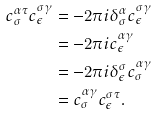Convert formula to latex. <formula><loc_0><loc_0><loc_500><loc_500>c _ { \sigma } ^ { \alpha \tau } c _ { \epsilon } ^ { \sigma \gamma } & = - 2 \pi i \delta ^ { \alpha } _ { \sigma } c _ { \epsilon } ^ { \sigma \gamma } \\ & = - 2 \pi i c _ { \epsilon } ^ { \alpha \gamma } \\ & = - 2 \pi i \delta _ { \epsilon } ^ { \sigma } c _ { \sigma } ^ { \alpha \gamma } \\ & = c _ { \sigma } ^ { \alpha \gamma } c _ { \epsilon } ^ { \sigma \tau } .</formula> 